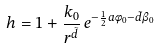<formula> <loc_0><loc_0><loc_500><loc_500>h = 1 + \frac { k _ { 0 } } { r ^ { \tilde { d } } } \, e ^ { - \frac { 1 } { 2 } a \phi _ { 0 } - \tilde { d } \beta _ { 0 } }</formula> 